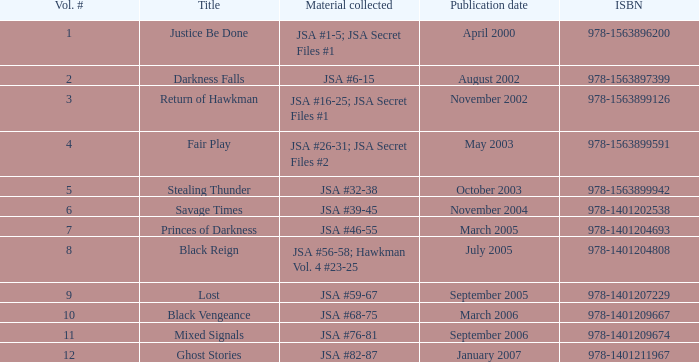For the isbn 978-1401209674, what content has been compiled? JSA #76-81. Could you help me parse every detail presented in this table? {'header': ['Vol. #', 'Title', 'Material collected', 'Publication date', 'ISBN'], 'rows': [['1', 'Justice Be Done', 'JSA #1-5; JSA Secret Files #1', 'April 2000', '978-1563896200'], ['2', 'Darkness Falls', 'JSA #6-15', 'August 2002', '978-1563897399'], ['3', 'Return of Hawkman', 'JSA #16-25; JSA Secret Files #1', 'November 2002', '978-1563899126'], ['4', 'Fair Play', 'JSA #26-31; JSA Secret Files #2', 'May 2003', '978-1563899591'], ['5', 'Stealing Thunder', 'JSA #32-38', 'October 2003', '978-1563899942'], ['6', 'Savage Times', 'JSA #39-45', 'November 2004', '978-1401202538'], ['7', 'Princes of Darkness', 'JSA #46-55', 'March 2005', '978-1401204693'], ['8', 'Black Reign', 'JSA #56-58; Hawkman Vol. 4 #23-25', 'July 2005', '978-1401204808'], ['9', 'Lost', 'JSA #59-67', 'September 2005', '978-1401207229'], ['10', 'Black Vengeance', 'JSA #68-75', 'March 2006', '978-1401209667'], ['11', 'Mixed Signals', 'JSA #76-81', 'September 2006', '978-1401209674'], ['12', 'Ghost Stories', 'JSA #82-87', 'January 2007', '978-1401211967']]} 